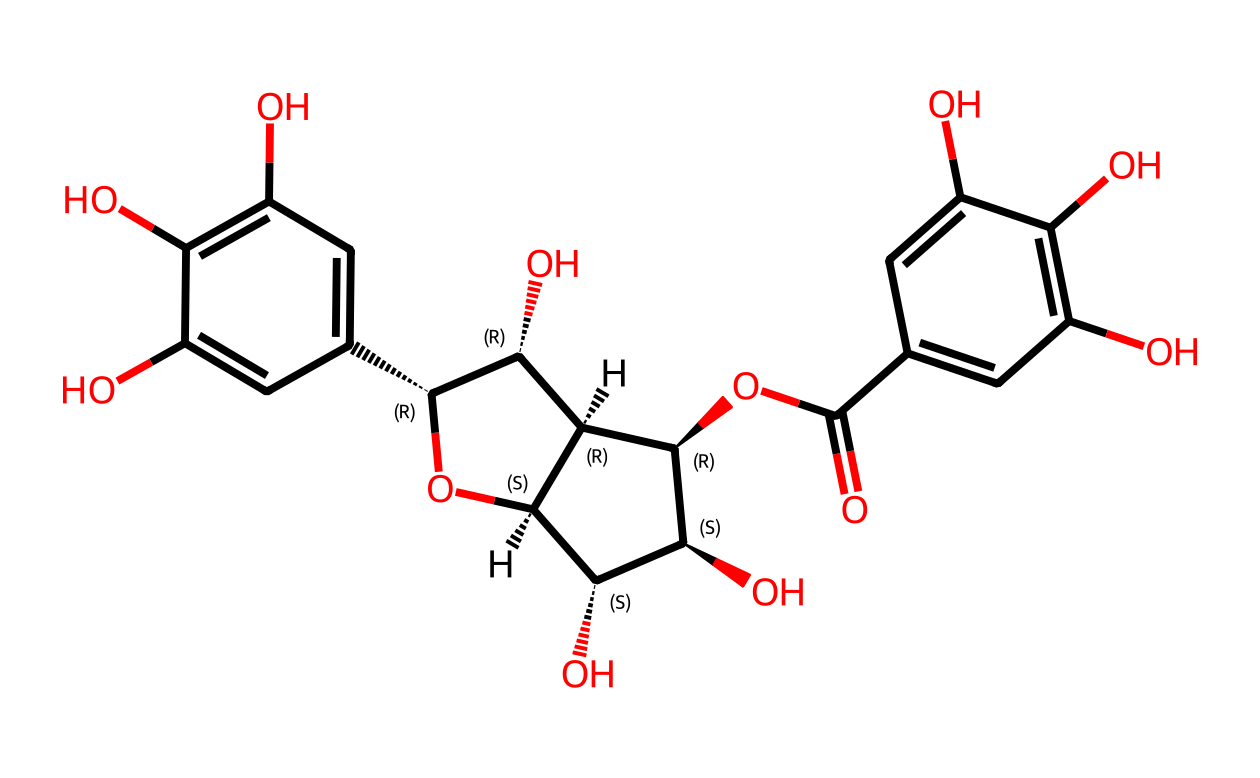What is the main functional group present in catechins? The structural formula indicates the presence of hydroxyl (-OH) groups attached to the aromatic rings and other parts of the molecule, which are characteristic of phenolic compounds.
Answer: hydroxyl How many ring structures are in the catechin molecule? By examining the SMILES representation, we can identify two fused ring systems that are typical to flavonoids; specifically, there are two aromatic rings that form a significant part of the structure.
Answer: two What type of chemical compound is catechin classified as? Catechin consists of multiple phenolic groups and is recognized as a flavonoid, a subclass of polyphenolic compounds noted for their antioxidant properties.
Answer: flavonoid What is the total number of carbon atoms in the catechin structure? Counting the carbon atoms represented in the structural formula from the SMILES string, a total of fifteen carbon atoms can be identified, highlighting its complex molecular framework.
Answer: fifteen Which part of the catechin structure contributes to its antioxidant properties? The presence of multiple hydroxyl groups indicates high electron-donating capacity, enhancing the molecule's ability to neutralize free radicals, thereby conferring antioxidant properties.
Answer: hydroxyl groups How many hydroxyl (-OH) groups are found in the catechin molecule? By closely analyzing the SMILES notation, we can count the specific occurrences of hydroxyl groups within the structure, leading us to find that there are five hydroxyl groups total.
Answer: five What distinguishes catechin as a type of antioxidant? The arrangement and functionality of the hydroxyl groups on the aromatic rings in catechin increase its reactivity towards free radicals, allowing it to act as a strong antioxidant.
Answer: reactivity 